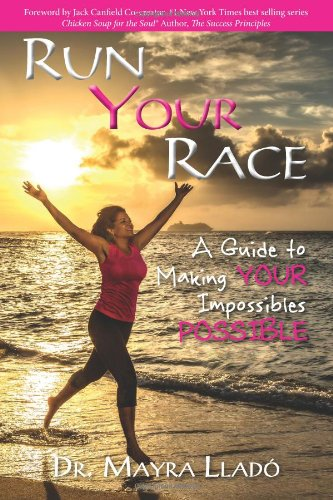What is the genre of this book? This book belongs to the Self-Help genre, focusing on personal growth and maximizing one's potential through inspirational and motivational guidance. 